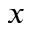Convert formula to latex. <formula><loc_0><loc_0><loc_500><loc_500>_ { x }</formula> 